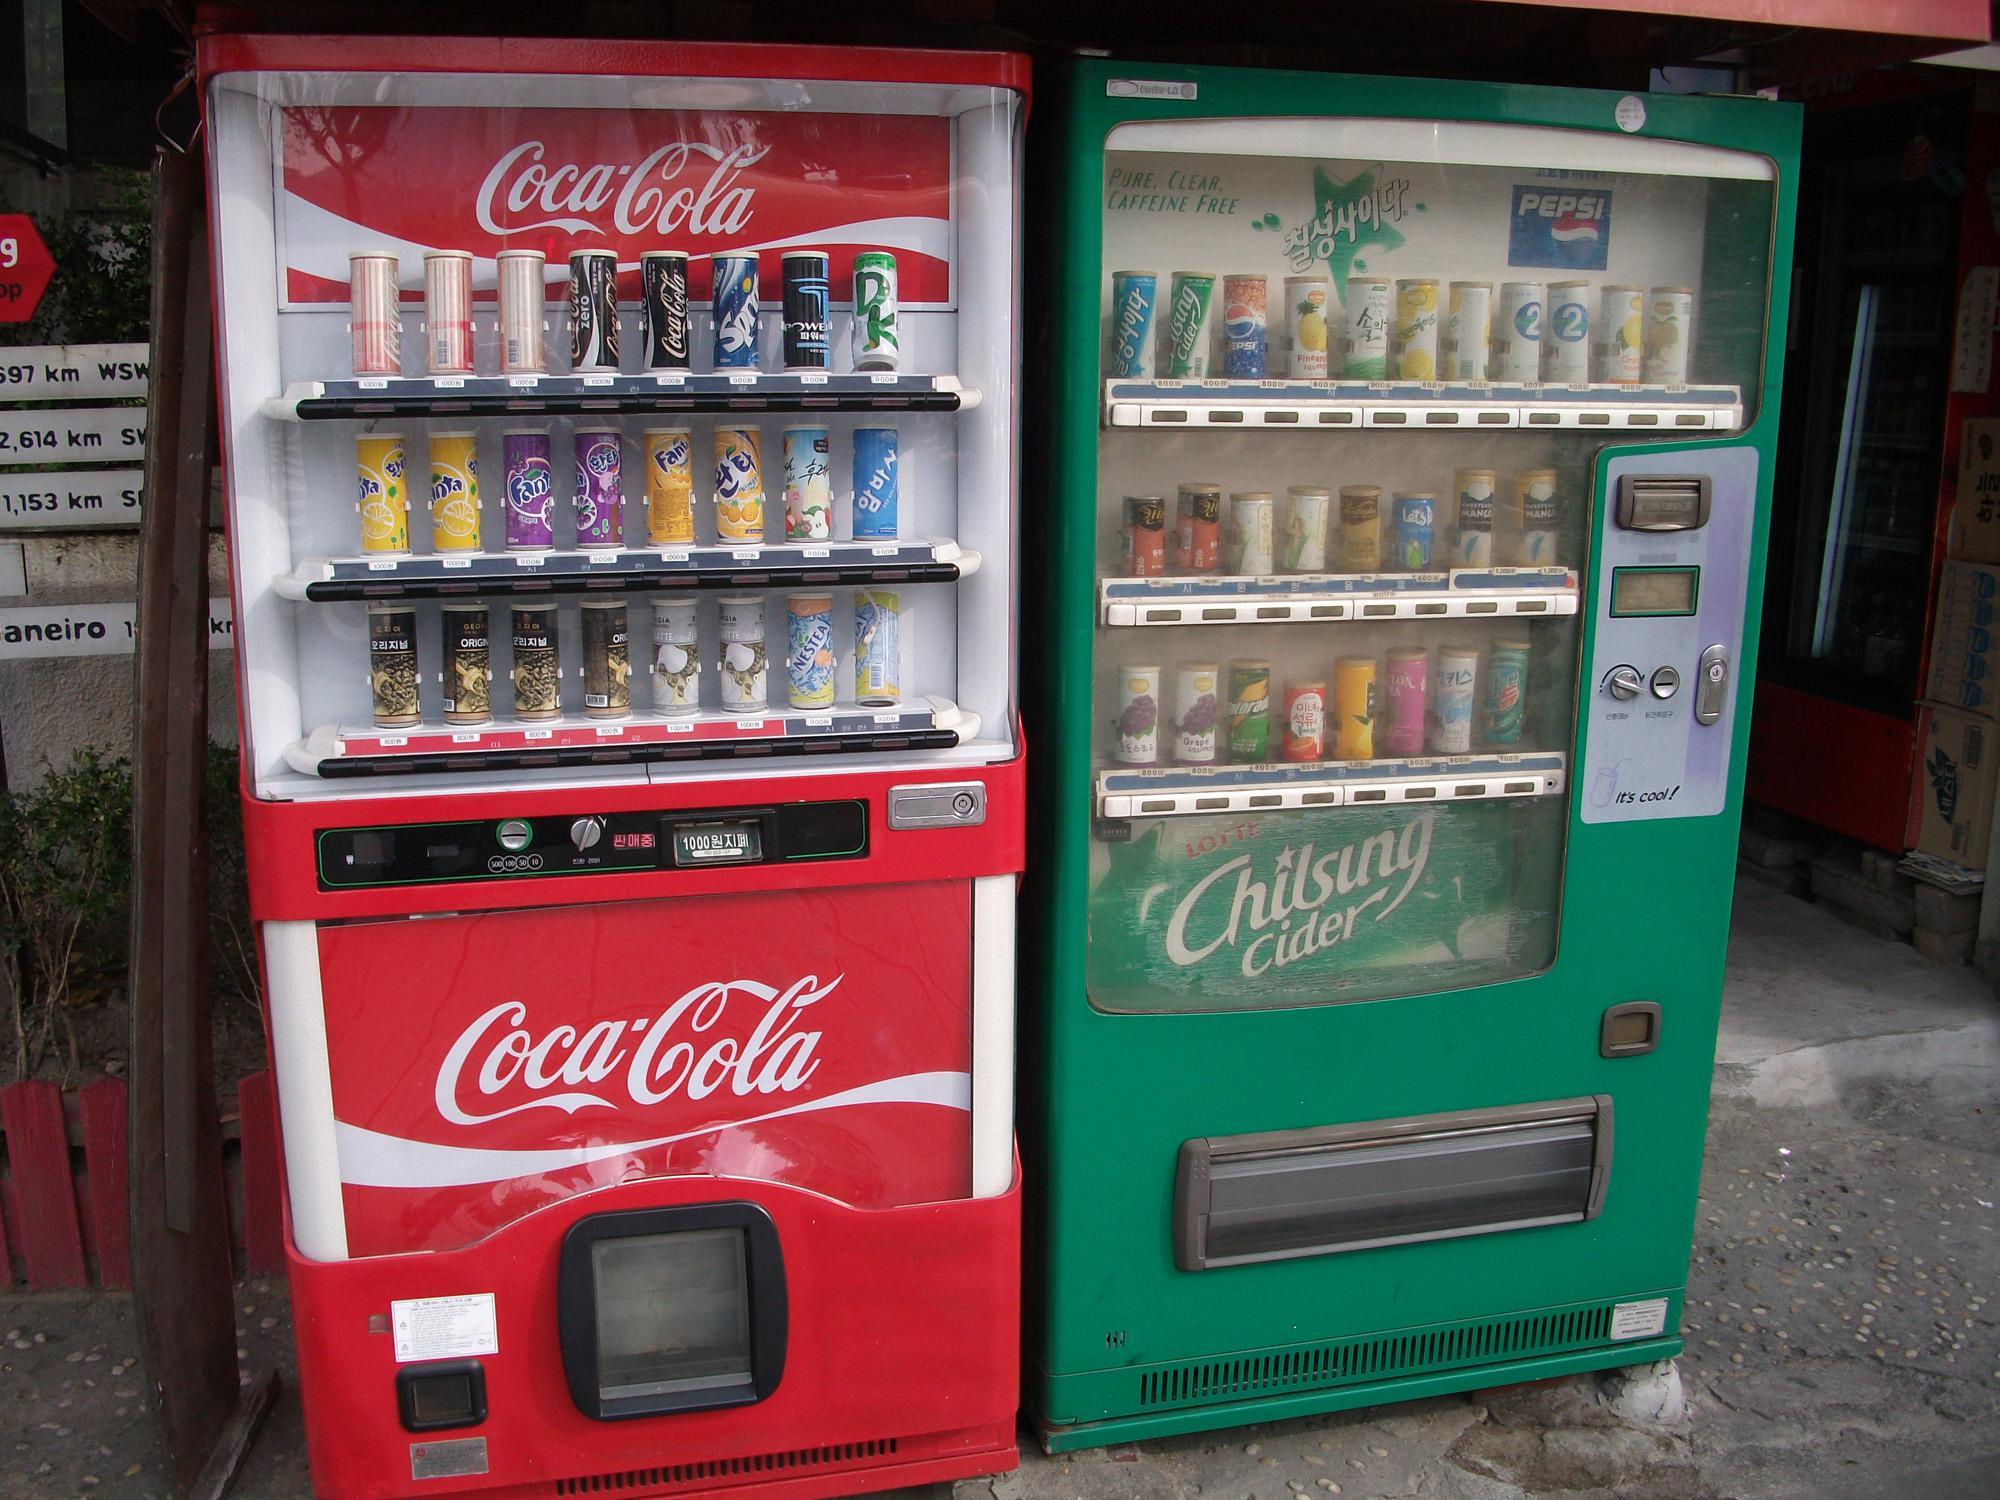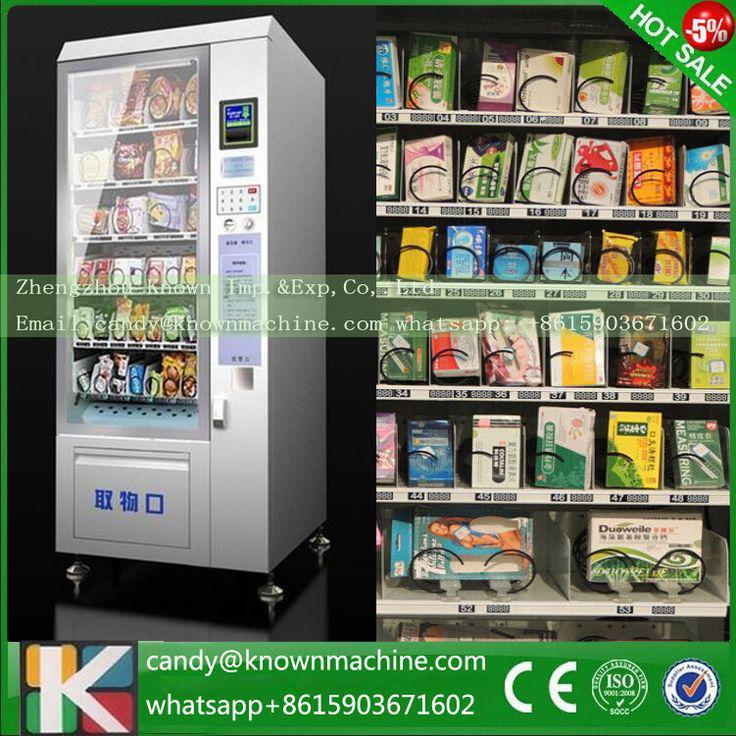The first image is the image on the left, the second image is the image on the right. Given the left and right images, does the statement "There are at least three vending machines that have food or drinks." hold true? Answer yes or no. Yes. 